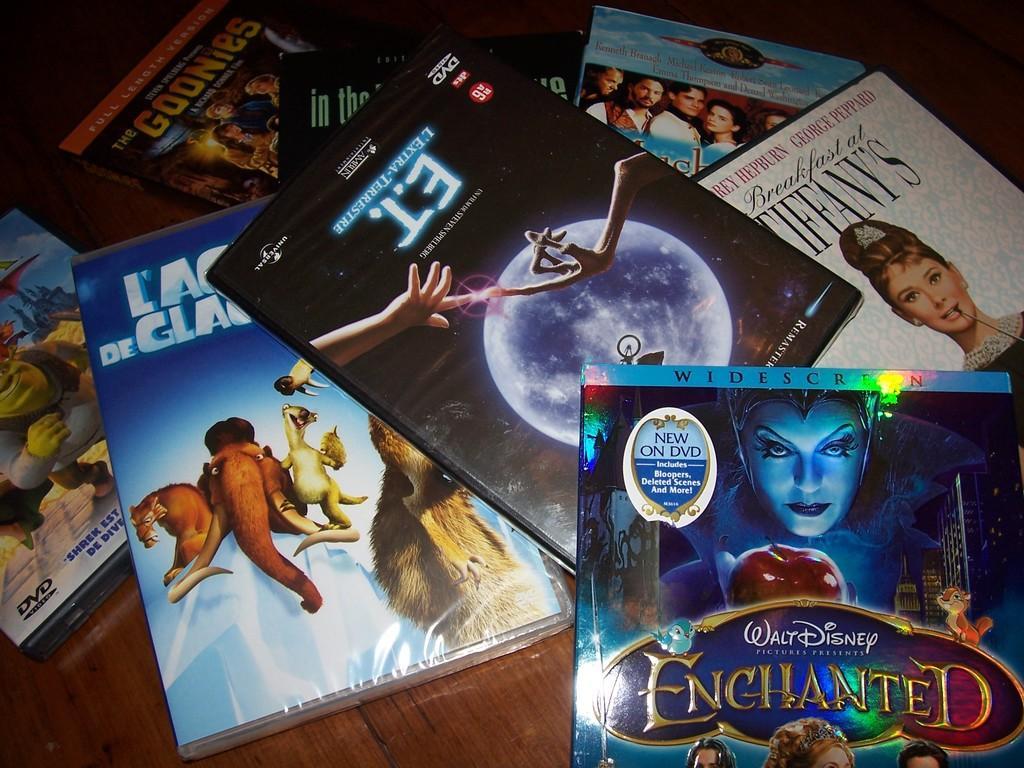Describe this image in one or two sentences. In this image we can see the boxes on a wooden surface. On the boxes we can see the text and images. 